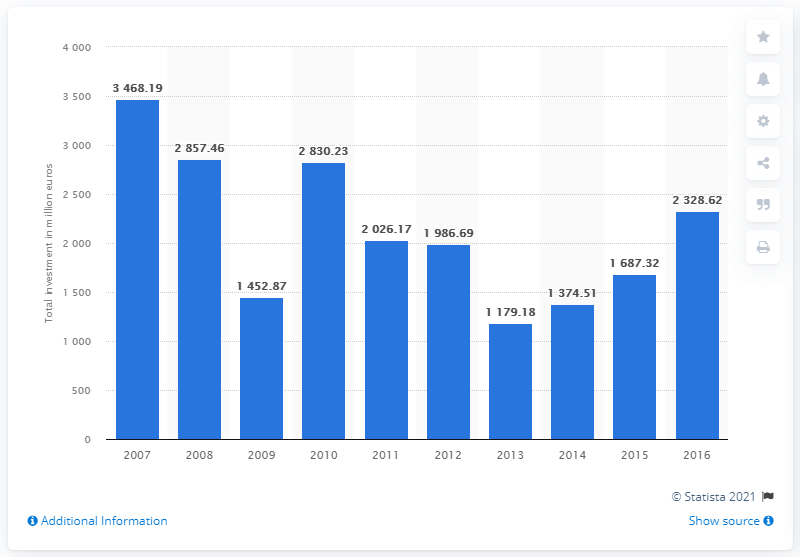Point out several critical features in this image. In 2016, the value of private equity investments in Spain was approximately 2328.62. In 2007, the total value of private equity investments was 3468.19. 